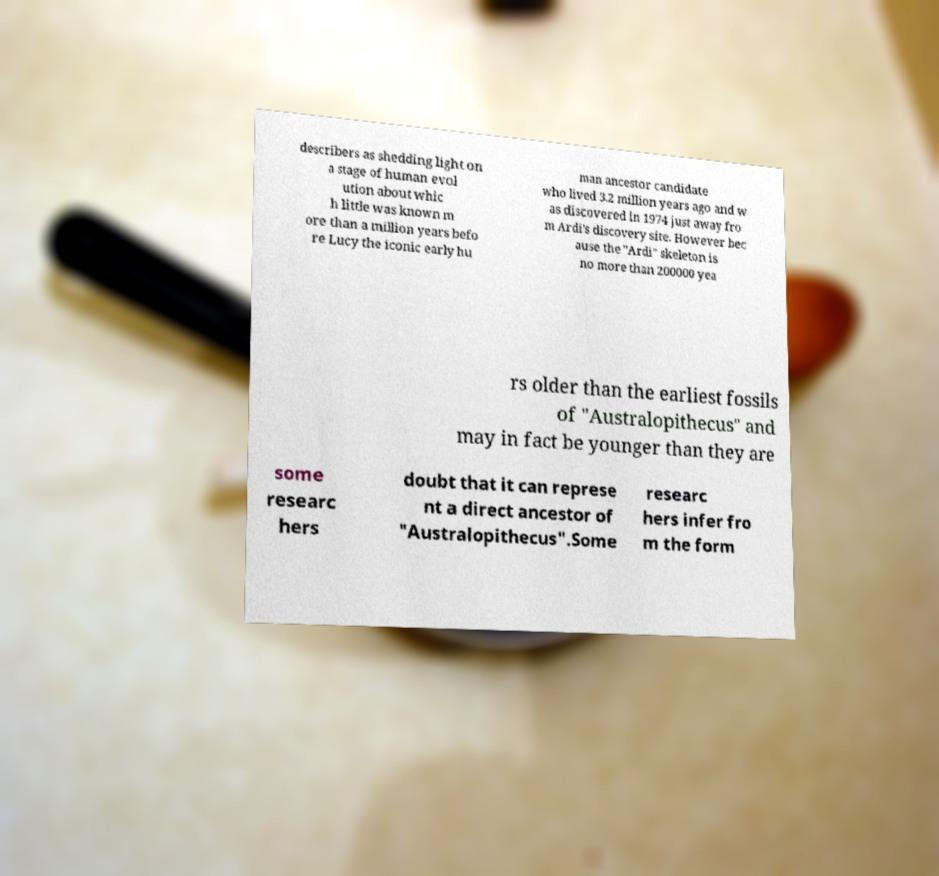Can you read and provide the text displayed in the image?This photo seems to have some interesting text. Can you extract and type it out for me? describers as shedding light on a stage of human evol ution about whic h little was known m ore than a million years befo re Lucy the iconic early hu man ancestor candidate who lived 3.2 million years ago and w as discovered in 1974 just away fro m Ardi's discovery site. However bec ause the "Ardi" skeleton is no more than 200000 yea rs older than the earliest fossils of "Australopithecus" and may in fact be younger than they are some researc hers doubt that it can represe nt a direct ancestor of "Australopithecus".Some researc hers infer fro m the form 